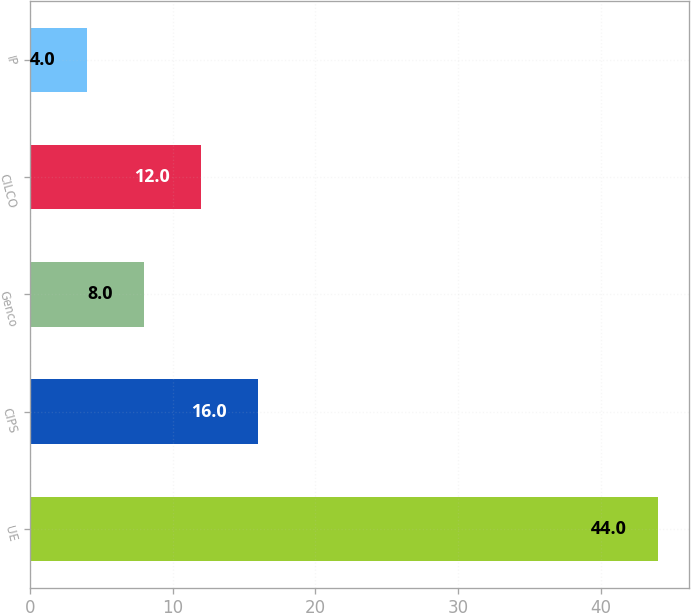Convert chart to OTSL. <chart><loc_0><loc_0><loc_500><loc_500><bar_chart><fcel>UE<fcel>CIPS<fcel>Genco<fcel>CILCO<fcel>IP<nl><fcel>44<fcel>16<fcel>8<fcel>12<fcel>4<nl></chart> 